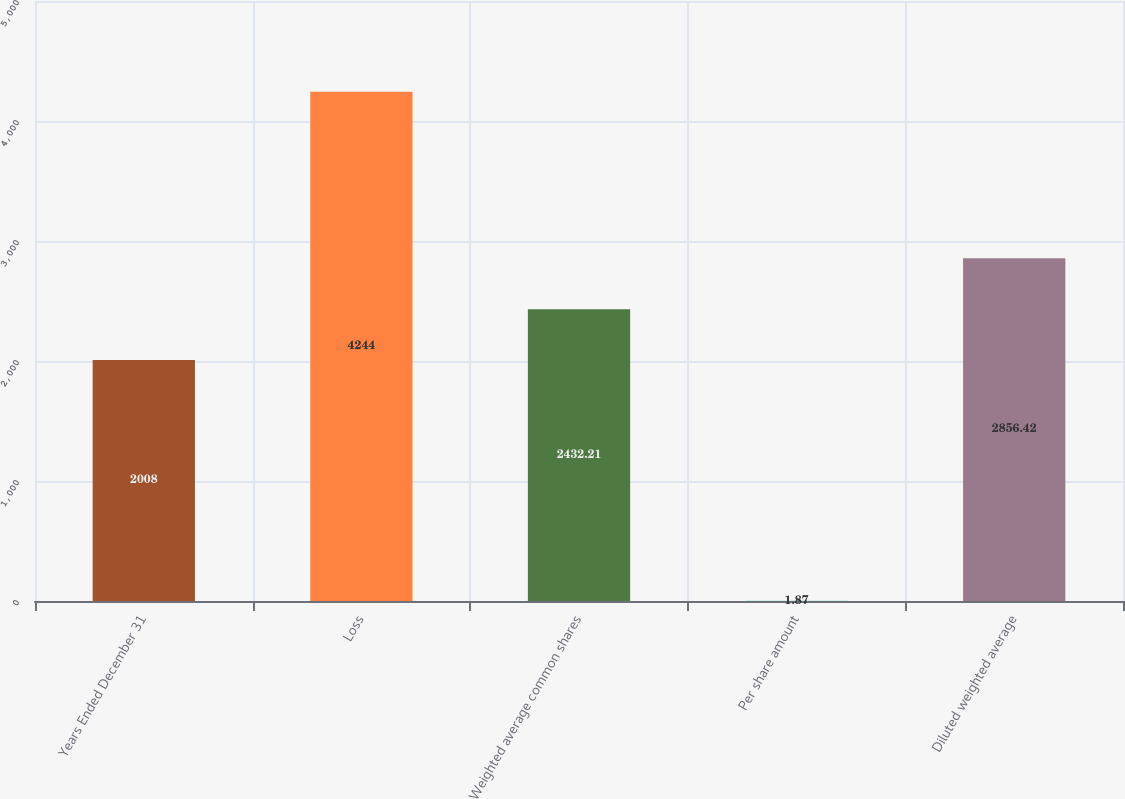Convert chart to OTSL. <chart><loc_0><loc_0><loc_500><loc_500><bar_chart><fcel>Years Ended December 31<fcel>Loss<fcel>Weighted average common shares<fcel>Per share amount<fcel>Diluted weighted average<nl><fcel>2008<fcel>4244<fcel>2432.21<fcel>1.87<fcel>2856.42<nl></chart> 